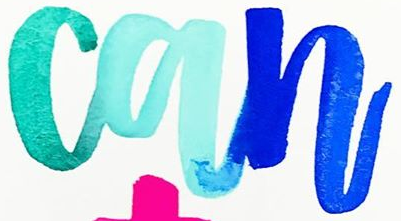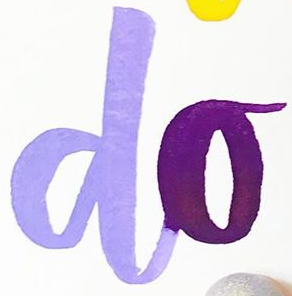Transcribe the words shown in these images in order, separated by a semicolon. can; do 